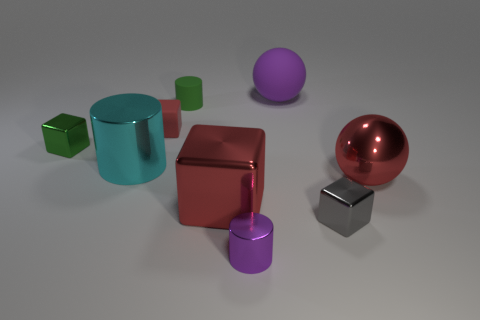Are there fewer tiny cylinders on the left side of the small purple cylinder than small rubber objects?
Keep it short and to the point. Yes. There is a tiny purple thing; are there any large objects on the left side of it?
Keep it short and to the point. Yes. Is there another purple matte object of the same shape as the purple matte thing?
Offer a very short reply. No. What shape is the red matte thing that is the same size as the gray cube?
Ensure brevity in your answer.  Cube. What number of objects are either large red objects left of the tiny gray shiny thing or large gray metallic objects?
Your answer should be compact. 1. Is the color of the rubber cube the same as the small rubber cylinder?
Your response must be concise. No. What is the size of the purple thing that is left of the purple sphere?
Make the answer very short. Small. Is there a gray block that has the same size as the green shiny block?
Your answer should be compact. Yes. Does the purple object in front of the red metal cube have the same size as the purple rubber ball?
Your response must be concise. No. The green metallic object is what size?
Your answer should be very brief. Small. 